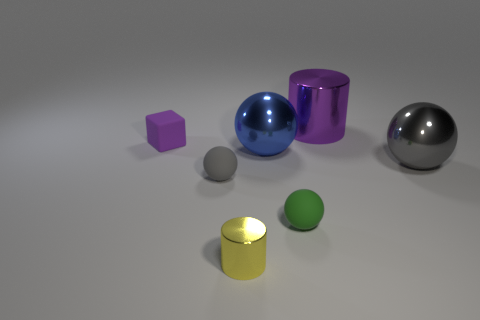Are there any large blue shiny cubes?
Provide a succinct answer. No. What color is the other tiny matte thing that is the same shape as the green rubber object?
Give a very brief answer. Gray. Do the matte object that is behind the blue sphere and the small metallic object have the same color?
Provide a succinct answer. No. Is the yellow shiny object the same size as the purple cube?
Offer a terse response. Yes. What shape is the gray thing that is made of the same material as the small yellow cylinder?
Ensure brevity in your answer.  Sphere. How many other things are there of the same shape as the yellow metal thing?
Give a very brief answer. 1. There is a gray thing that is left of the gray thing that is to the right of the big metal thing behind the matte block; what is its shape?
Make the answer very short. Sphere. How many cylinders are either purple things or yellow metal things?
Provide a short and direct response. 2. There is a rubber thing that is right of the large blue shiny ball; are there any purple matte blocks that are to the left of it?
Provide a short and direct response. Yes. Is the shape of the small yellow thing the same as the gray thing that is right of the tiny metallic cylinder?
Make the answer very short. No. 